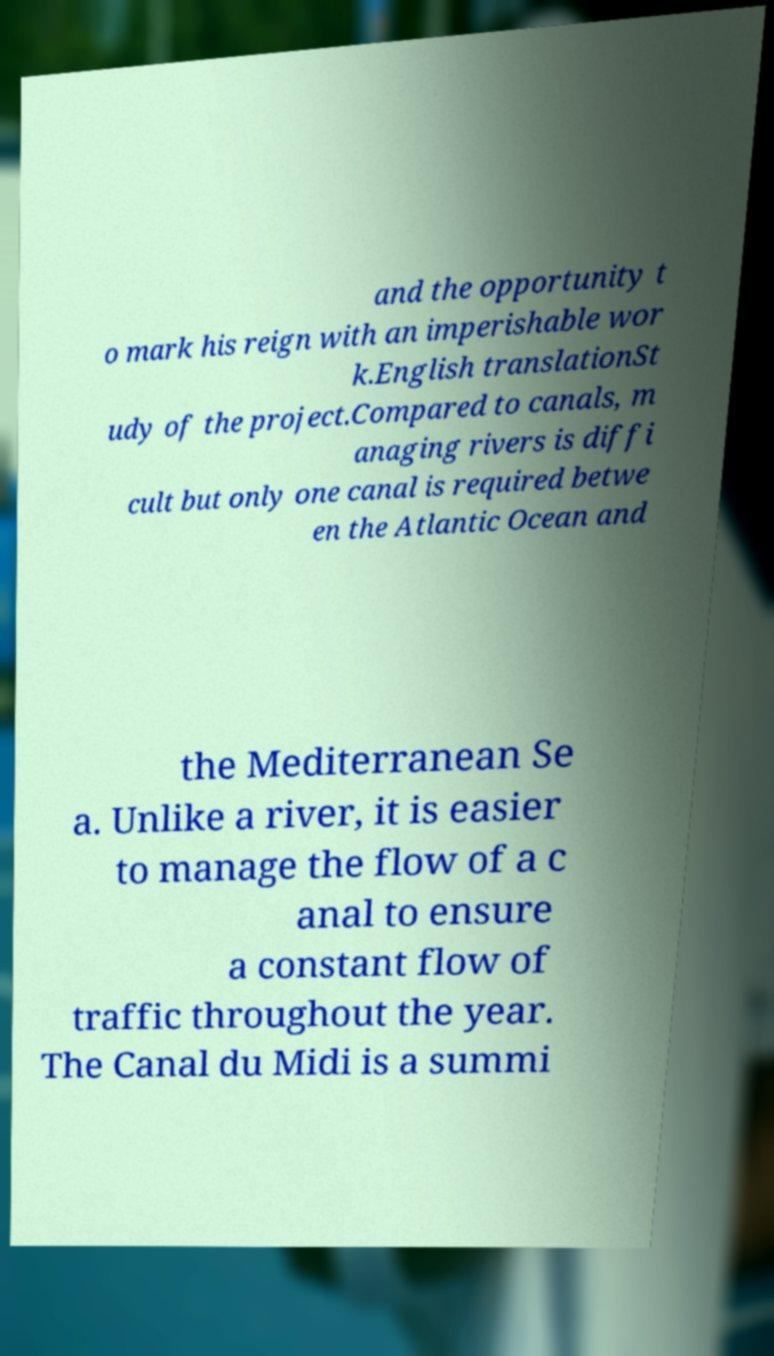Can you accurately transcribe the text from the provided image for me? and the opportunity t o mark his reign with an imperishable wor k.English translationSt udy of the project.Compared to canals, m anaging rivers is diffi cult but only one canal is required betwe en the Atlantic Ocean and the Mediterranean Se a. Unlike a river, it is easier to manage the flow of a c anal to ensure a constant flow of traffic throughout the year. The Canal du Midi is a summi 